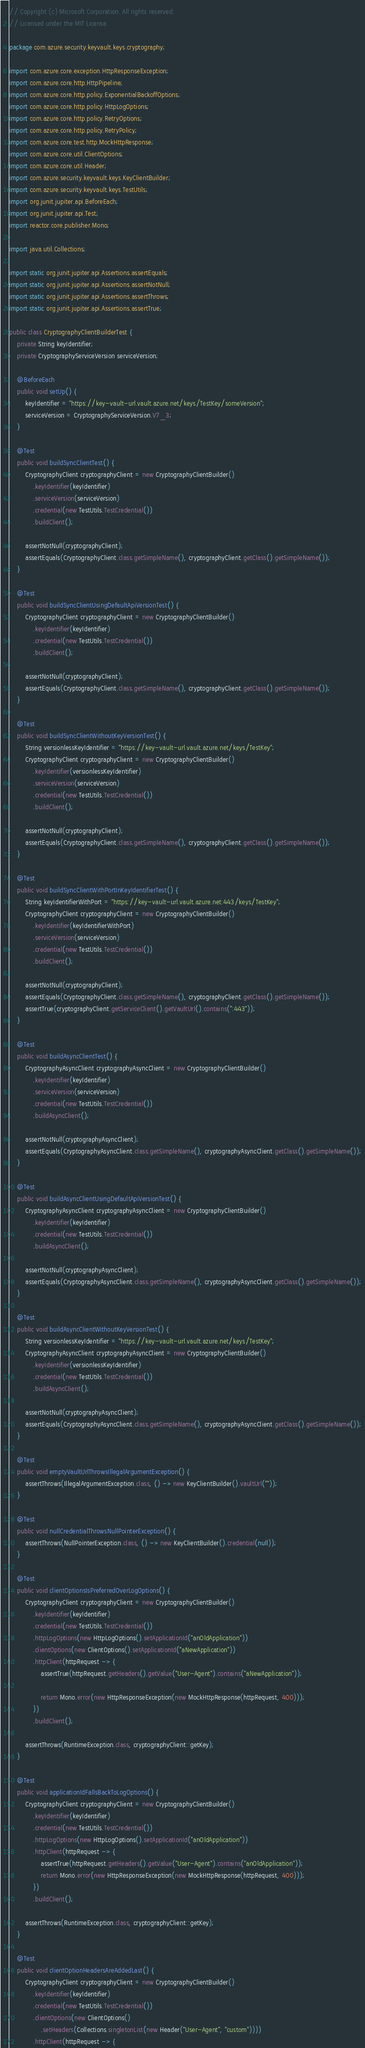<code> <loc_0><loc_0><loc_500><loc_500><_Java_>// Copyright (c) Microsoft Corporation. All rights reserved.
// Licensed under the MIT License.

package com.azure.security.keyvault.keys.cryptography;

import com.azure.core.exception.HttpResponseException;
import com.azure.core.http.HttpPipeline;
import com.azure.core.http.policy.ExponentialBackoffOptions;
import com.azure.core.http.policy.HttpLogOptions;
import com.azure.core.http.policy.RetryOptions;
import com.azure.core.http.policy.RetryPolicy;
import com.azure.core.test.http.MockHttpResponse;
import com.azure.core.util.ClientOptions;
import com.azure.core.util.Header;
import com.azure.security.keyvault.keys.KeyClientBuilder;
import com.azure.security.keyvault.keys.TestUtils;
import org.junit.jupiter.api.BeforeEach;
import org.junit.jupiter.api.Test;
import reactor.core.publisher.Mono;

import java.util.Collections;

import static org.junit.jupiter.api.Assertions.assertEquals;
import static org.junit.jupiter.api.Assertions.assertNotNull;
import static org.junit.jupiter.api.Assertions.assertThrows;
import static org.junit.jupiter.api.Assertions.assertTrue;

public class CryptographyClientBuilderTest {
    private String keyIdentifier;
    private CryptographyServiceVersion serviceVersion;

    @BeforeEach
    public void setUp() {
        keyIdentifier = "https://key-vault-url.vault.azure.net/keys/TestKey/someVersion";
        serviceVersion = CryptographyServiceVersion.V7_3;
    }

    @Test
    public void buildSyncClientTest() {
        CryptographyClient cryptographyClient = new CryptographyClientBuilder()
            .keyIdentifier(keyIdentifier)
            .serviceVersion(serviceVersion)
            .credential(new TestUtils.TestCredential())
            .buildClient();

        assertNotNull(cryptographyClient);
        assertEquals(CryptographyClient.class.getSimpleName(), cryptographyClient.getClass().getSimpleName());
    }

    @Test
    public void buildSyncClientUsingDefaultApiVersionTest() {
        CryptographyClient cryptographyClient = new CryptographyClientBuilder()
            .keyIdentifier(keyIdentifier)
            .credential(new TestUtils.TestCredential())
            .buildClient();

        assertNotNull(cryptographyClient);
        assertEquals(CryptographyClient.class.getSimpleName(), cryptographyClient.getClass().getSimpleName());
    }

    @Test
    public void buildSyncClientWithoutKeyVersionTest() {
        String versionlessKeyIdentifier = "https://key-vault-url.vault.azure.net/keys/TestKey";
        CryptographyClient cryptographyClient = new CryptographyClientBuilder()
            .keyIdentifier(versionlessKeyIdentifier)
            .serviceVersion(serviceVersion)
            .credential(new TestUtils.TestCredential())
            .buildClient();

        assertNotNull(cryptographyClient);
        assertEquals(CryptographyClient.class.getSimpleName(), cryptographyClient.getClass().getSimpleName());
    }

    @Test
    public void buildSyncClientWithPortInKeyIdentifierTest() {
        String keyIdentifierWithPort = "https://key-vault-url.vault.azure.net:443/keys/TestKey";
        CryptographyClient cryptographyClient = new CryptographyClientBuilder()
            .keyIdentifier(keyIdentifierWithPort)
            .serviceVersion(serviceVersion)
            .credential(new TestUtils.TestCredential())
            .buildClient();

        assertNotNull(cryptographyClient);
        assertEquals(CryptographyClient.class.getSimpleName(), cryptographyClient.getClass().getSimpleName());
        assertTrue(cryptographyClient.getServiceClient().getVaultUrl().contains(":443"));
    }

    @Test
    public void buildAsyncClientTest() {
        CryptographyAsyncClient cryptographyAsyncClient = new CryptographyClientBuilder()
            .keyIdentifier(keyIdentifier)
            .serviceVersion(serviceVersion)
            .credential(new TestUtils.TestCredential())
            .buildAsyncClient();

        assertNotNull(cryptographyAsyncClient);
        assertEquals(CryptographyAsyncClient.class.getSimpleName(), cryptographyAsyncClient.getClass().getSimpleName());
    }

    @Test
    public void buildAsyncClientUsingDefaultApiVersionTest() {
        CryptographyAsyncClient cryptographyAsyncClient = new CryptographyClientBuilder()
            .keyIdentifier(keyIdentifier)
            .credential(new TestUtils.TestCredential())
            .buildAsyncClient();

        assertNotNull(cryptographyAsyncClient);
        assertEquals(CryptographyAsyncClient.class.getSimpleName(), cryptographyAsyncClient.getClass().getSimpleName());
    }

    @Test
    public void buildAsyncClientWithoutKeyVersionTest() {
        String versionlessKeyIdentifier = "https://key-vault-url.vault.azure.net/keys/TestKey";
        CryptographyAsyncClient cryptographyAsyncClient = new CryptographyClientBuilder()
            .keyIdentifier(versionlessKeyIdentifier)
            .credential(new TestUtils.TestCredential())
            .buildAsyncClient();

        assertNotNull(cryptographyAsyncClient);
        assertEquals(CryptographyAsyncClient.class.getSimpleName(), cryptographyAsyncClient.getClass().getSimpleName());
    }

    @Test
    public void emptyVaultUrlThrowsIllegalArgumentException() {
        assertThrows(IllegalArgumentException.class, () -> new KeyClientBuilder().vaultUrl(""));
    }

    @Test
    public void nullCredentialThrowsNullPointerException() {
        assertThrows(NullPointerException.class, () -> new KeyClientBuilder().credential(null));
    }

    @Test
    public void clientOptionsIsPreferredOverLogOptions() {
        CryptographyClient cryptographyClient = new CryptographyClientBuilder()
            .keyIdentifier(keyIdentifier)
            .credential(new TestUtils.TestCredential())
            .httpLogOptions(new HttpLogOptions().setApplicationId("anOldApplication"))
            .clientOptions(new ClientOptions().setApplicationId("aNewApplication"))
            .httpClient(httpRequest -> {
                assertTrue(httpRequest.getHeaders().getValue("User-Agent").contains("aNewApplication"));

                return Mono.error(new HttpResponseException(new MockHttpResponse(httpRequest, 400)));
            })
            .buildClient();

        assertThrows(RuntimeException.class, cryptographyClient::getKey);
    }

    @Test
    public void applicationIdFallsBackToLogOptions() {
        CryptographyClient cryptographyClient = new CryptographyClientBuilder()
            .keyIdentifier(keyIdentifier)
            .credential(new TestUtils.TestCredential())
            .httpLogOptions(new HttpLogOptions().setApplicationId("anOldApplication"))
            .httpClient(httpRequest -> {
                assertTrue(httpRequest.getHeaders().getValue("User-Agent").contains("anOldApplication"));
                return Mono.error(new HttpResponseException(new MockHttpResponse(httpRequest, 400)));
            })
            .buildClient();

        assertThrows(RuntimeException.class, cryptographyClient::getKey);
    }

    @Test
    public void clientOptionHeadersAreAddedLast() {
        CryptographyClient cryptographyClient = new CryptographyClientBuilder()
            .keyIdentifier(keyIdentifier)
            .credential(new TestUtils.TestCredential())
            .clientOptions(new ClientOptions()
                .setHeaders(Collections.singletonList(new Header("User-Agent", "custom"))))
            .httpClient(httpRequest -> {</code> 